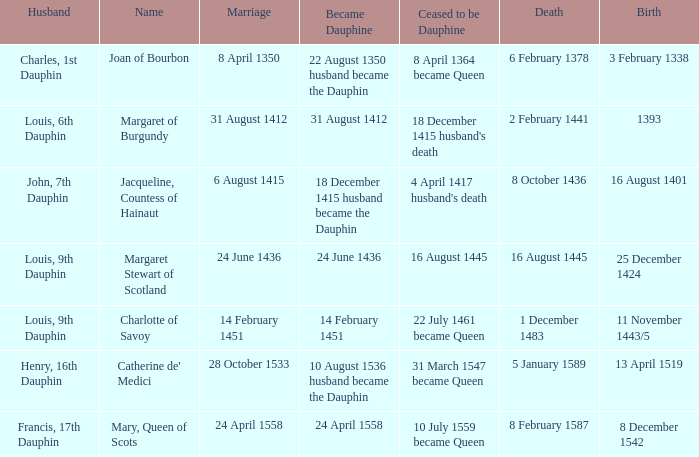When was the marriage when became dauphine is 31 august 1412? 31 August 1412. 